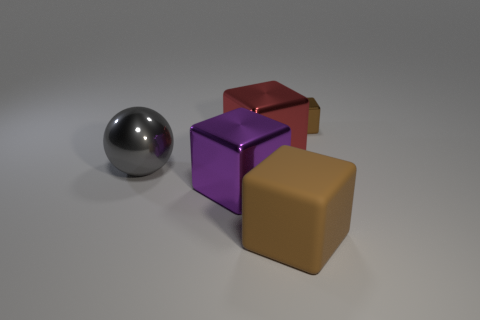There is a brown thing in front of the brown metal thing; how many large things are to the left of it?
Your answer should be very brief. 3. Is the number of brown metal objects in front of the big brown cube greater than the number of brown rubber cubes that are behind the red block?
Ensure brevity in your answer.  No. What is the purple block made of?
Provide a succinct answer. Metal. Are there any red metallic cylinders that have the same size as the gray sphere?
Your answer should be compact. No. What is the material of the red thing that is the same size as the brown rubber thing?
Provide a succinct answer. Metal. What number of large brown rubber spheres are there?
Ensure brevity in your answer.  0. There is a brown thing that is behind the brown matte object; how big is it?
Your answer should be compact. Small. Is the number of big purple metallic cubes that are behind the large metallic sphere the same as the number of purple shiny blocks?
Provide a short and direct response. No. Is there a small object of the same shape as the large brown thing?
Make the answer very short. Yes. There is a big shiny object that is both to the left of the large red shiny thing and to the right of the gray metal thing; what shape is it?
Your answer should be compact. Cube. 